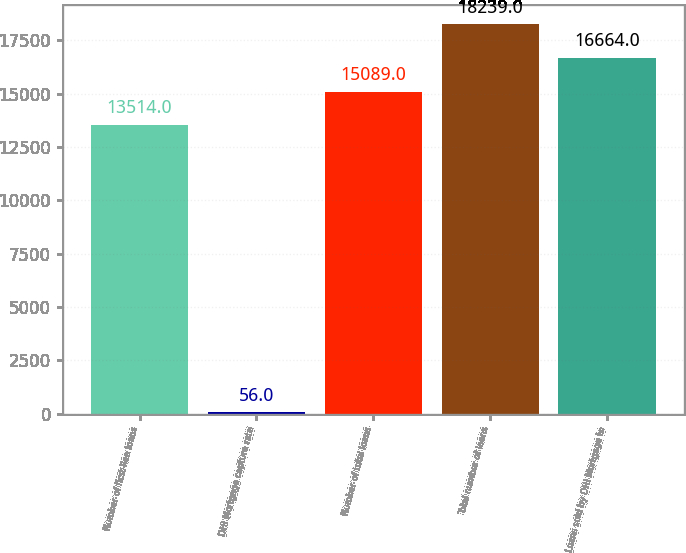<chart> <loc_0><loc_0><loc_500><loc_500><bar_chart><fcel>Number of first-lien loans<fcel>DHI Mortgage capture rate<fcel>Number of total loans<fcel>Total number of loans<fcel>Loans sold by DHI Mortgage to<nl><fcel>13514<fcel>56<fcel>15089<fcel>18239<fcel>16664<nl></chart> 